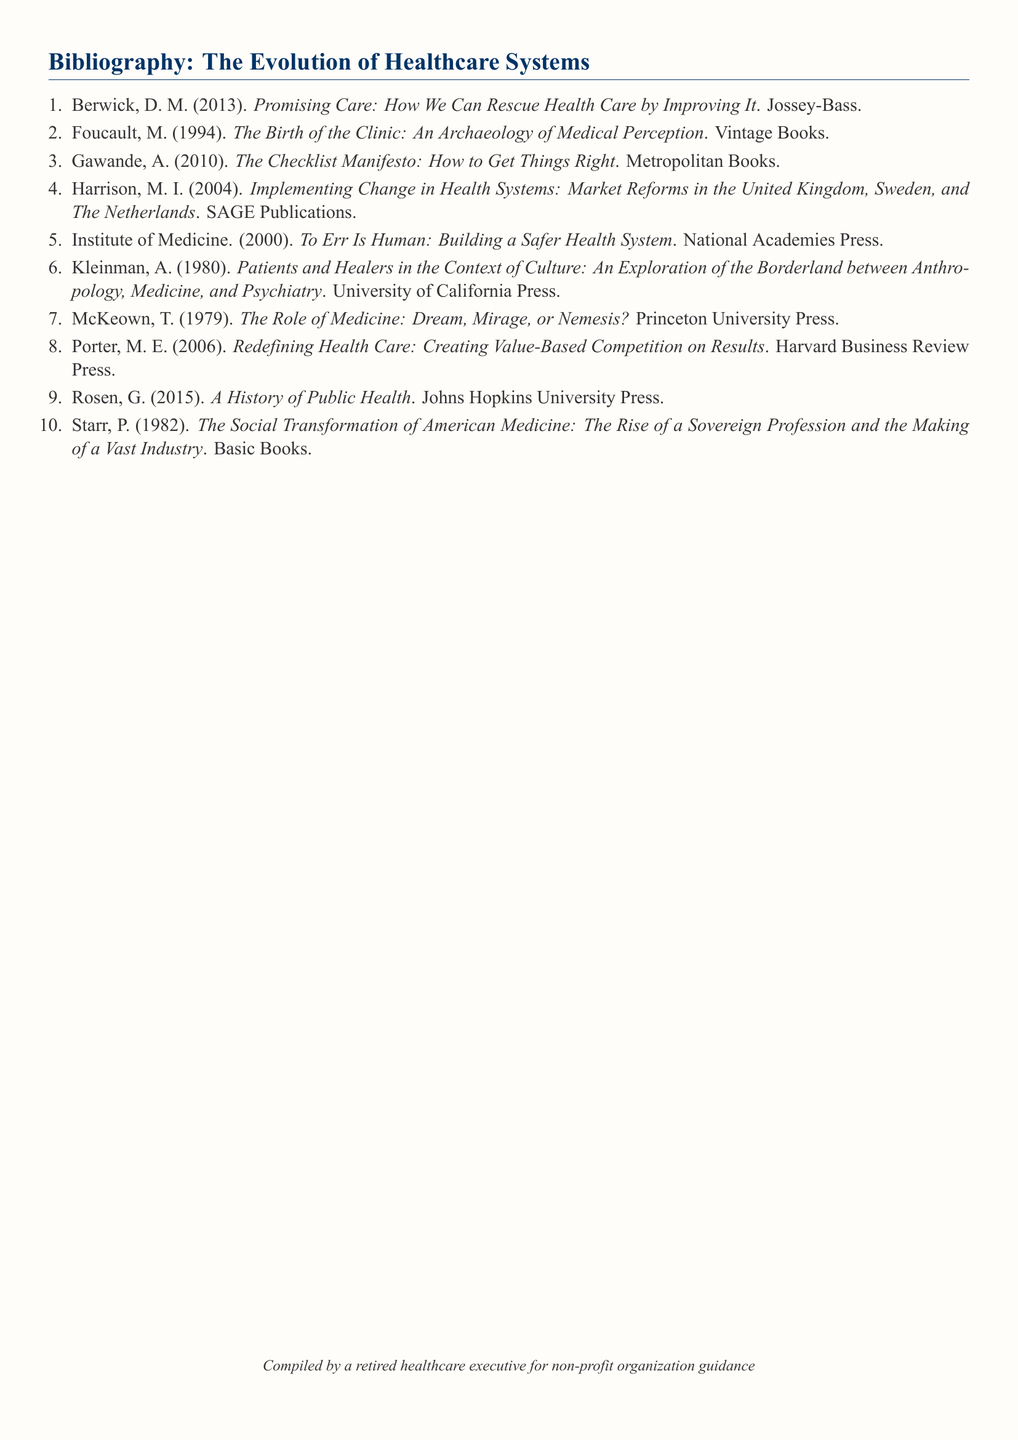What is the title of the first item in the bibliography? The title of the first item provides insight into the focus of healthcare improvement in the document.
Answer: Promising Care: How We Can Rescue Health Care by Improving It How many items are listed in the bibliography? The total number of items indicates the depth of the research topic in this document.
Answer: 10 Who is the author of "The Birth of the Clinic"? This question assesses knowledge of significant works in the evolution of healthcare systems within the document.
Answer: Foucault What year was "To Err Is Human" published? The publication year reflects the timing of important discussions regarding healthcare safety.
Answer: 2000 Which publisher released "The Social Transformation of American Medicine"? This question directly focuses on the publishing houses behind influential healthcare literature.
Answer: Basic Books What is the main theme explored in Kleinman's work? Understanding key themes helps connect the work to broader cultural implications in healthcare.
Answer: Patients and Healers in the Context of Culture Which author emphasizes value-based competition in healthcare? Identifying key contributions assists in understanding different approaches to healthcare delivery.
Answer: Porter How many of the listed works were published by SAGE Publications? This question looks at the prevalence of specific publication houses in the bibliography.
Answer: 1 What compilation role is stated at the end of the document? The role specified provides context for the expertise behind the document's compilation.
Answer: Compiled by a retired healthcare executive for non-profit organization guidance 